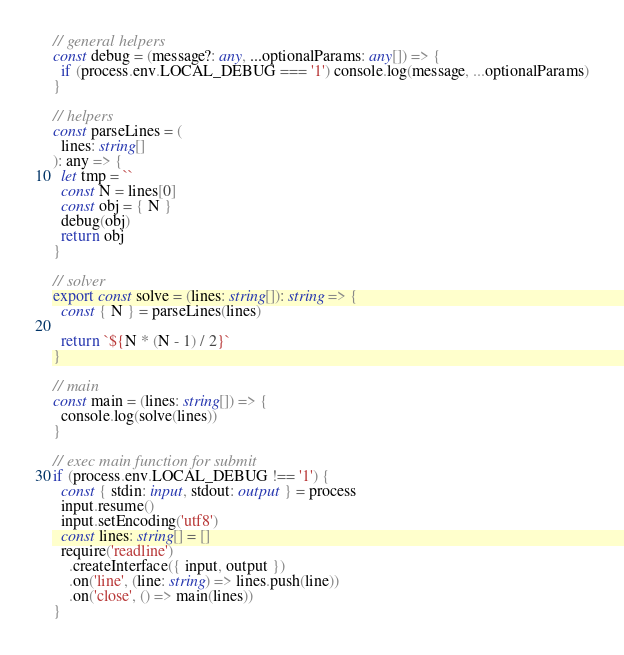Convert code to text. <code><loc_0><loc_0><loc_500><loc_500><_TypeScript_>// general helpers
const debug = (message?: any, ...optionalParams: any[]) => {
  if (process.env.LOCAL_DEBUG === '1') console.log(message, ...optionalParams)
}

// helpers
const parseLines = (
  lines: string[]
): any => {
  let tmp = ``
  const N = lines[0]
  const obj = { N }
  debug(obj)
  return obj
}

// solver
export const solve = (lines: string[]): string => {
  const { N } = parseLines(lines)

  return `${N * (N - 1) / 2}`
}

// main
const main = (lines: string[]) => {
  console.log(solve(lines))
}

// exec main function for submit
if (process.env.LOCAL_DEBUG !== '1') {
  const { stdin: input, stdout: output } = process
  input.resume()
  input.setEncoding('utf8')
  const lines: string[] = []
  require('readline')
    .createInterface({ input, output })
    .on('line', (line: string) => lines.push(line))
    .on('close', () => main(lines))
}
</code> 